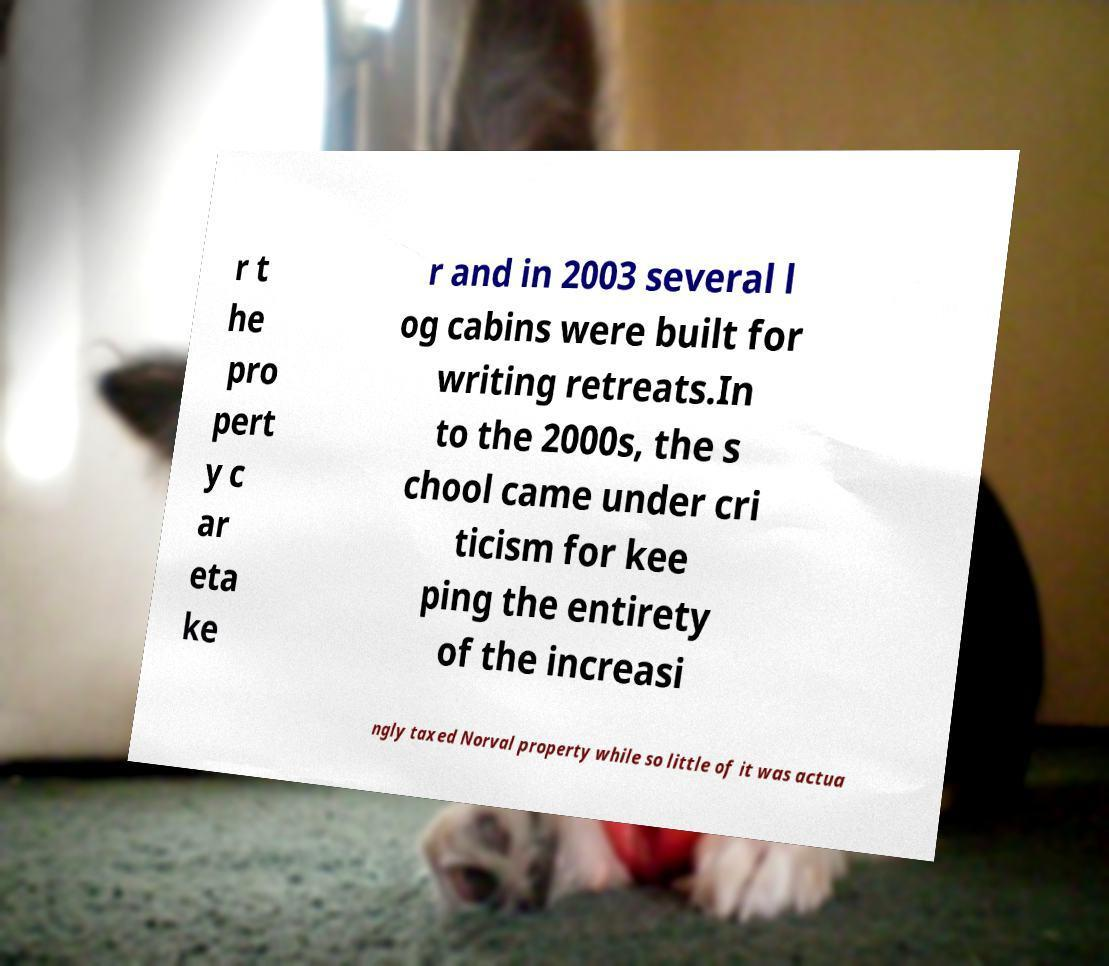Could you extract and type out the text from this image? r t he pro pert y c ar eta ke r and in 2003 several l og cabins were built for writing retreats.In to the 2000s, the s chool came under cri ticism for kee ping the entirety of the increasi ngly taxed Norval property while so little of it was actua 